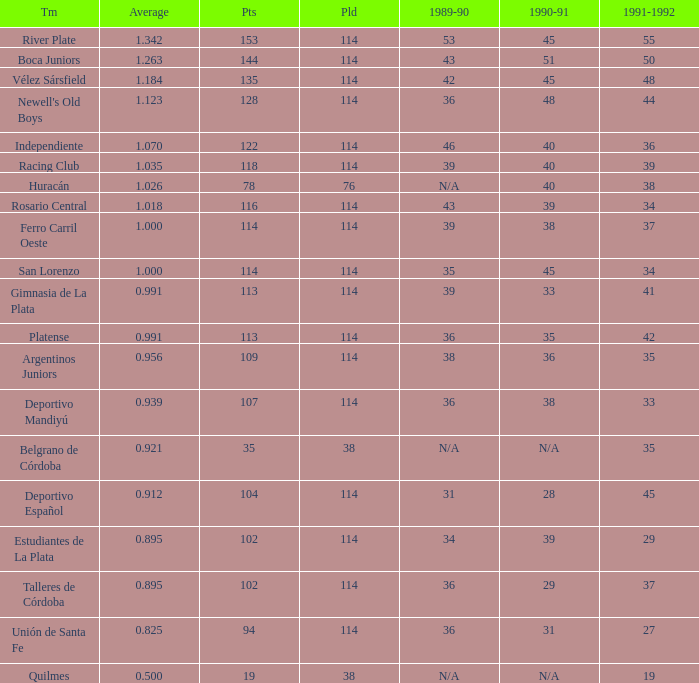How much Average has a 1989-90 of 36, and a Team of talleres de córdoba, and a Played smaller than 114? 0.0. 